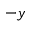Convert formula to latex. <formula><loc_0><loc_0><loc_500><loc_500>- y</formula> 